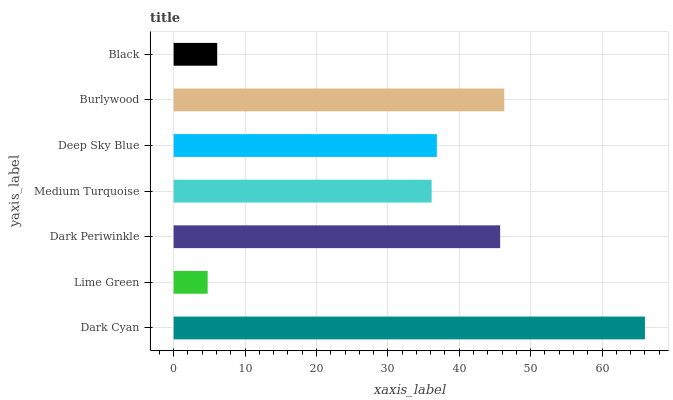Is Lime Green the minimum?
Answer yes or no. Yes. Is Dark Cyan the maximum?
Answer yes or no. Yes. Is Dark Periwinkle the minimum?
Answer yes or no. No. Is Dark Periwinkle the maximum?
Answer yes or no. No. Is Dark Periwinkle greater than Lime Green?
Answer yes or no. Yes. Is Lime Green less than Dark Periwinkle?
Answer yes or no. Yes. Is Lime Green greater than Dark Periwinkle?
Answer yes or no. No. Is Dark Periwinkle less than Lime Green?
Answer yes or no. No. Is Deep Sky Blue the high median?
Answer yes or no. Yes. Is Deep Sky Blue the low median?
Answer yes or no. Yes. Is Black the high median?
Answer yes or no. No. Is Dark Periwinkle the low median?
Answer yes or no. No. 